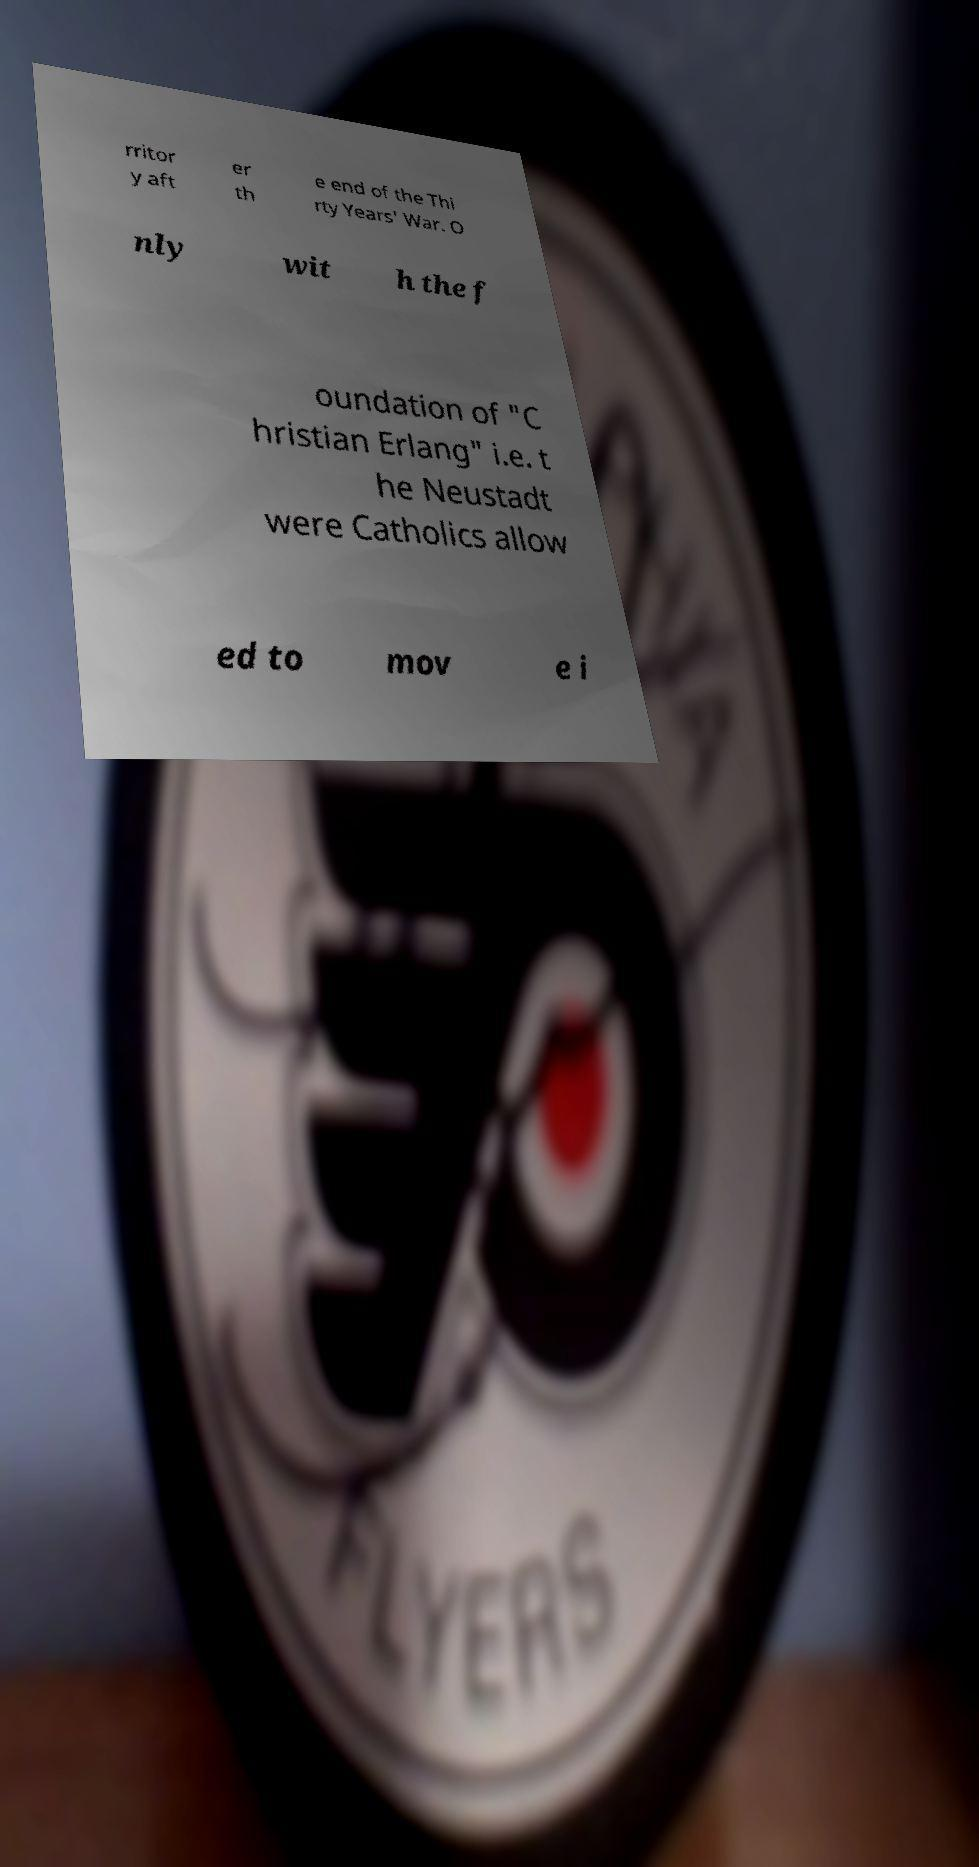I need the written content from this picture converted into text. Can you do that? rritor y aft er th e end of the Thi rty Years' War. O nly wit h the f oundation of "C hristian Erlang" i.e. t he Neustadt were Catholics allow ed to mov e i 